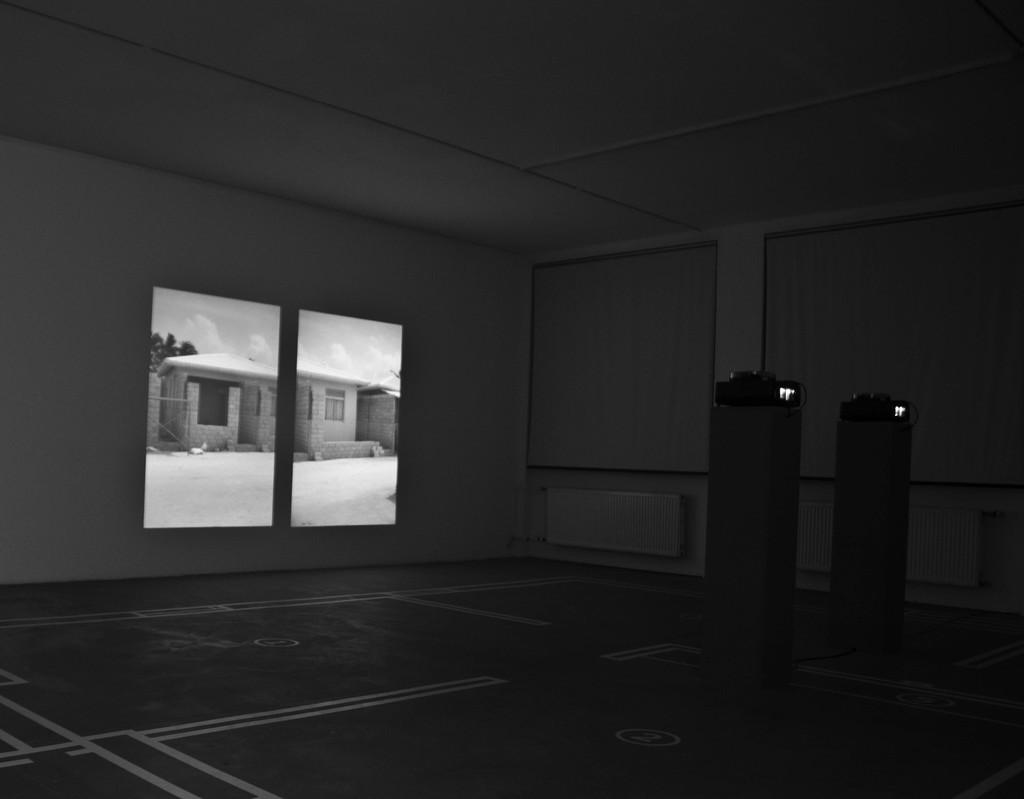What type of openings can be seen in the image? There are windows in the image. What type of structure is visible in the image? There is a building in the image. What type of vegetation is present in the image? There are trees in the image. What part of the natural environment is visible in the image? The sky is visible in the image. What is the perspective of the image? The image is an inside view of a room. Where is the throne located in the image? There is no throne present in the image. What type of furniture is used for sitting in the image? The image does not show any furniture for sitting, such as a sofa. 